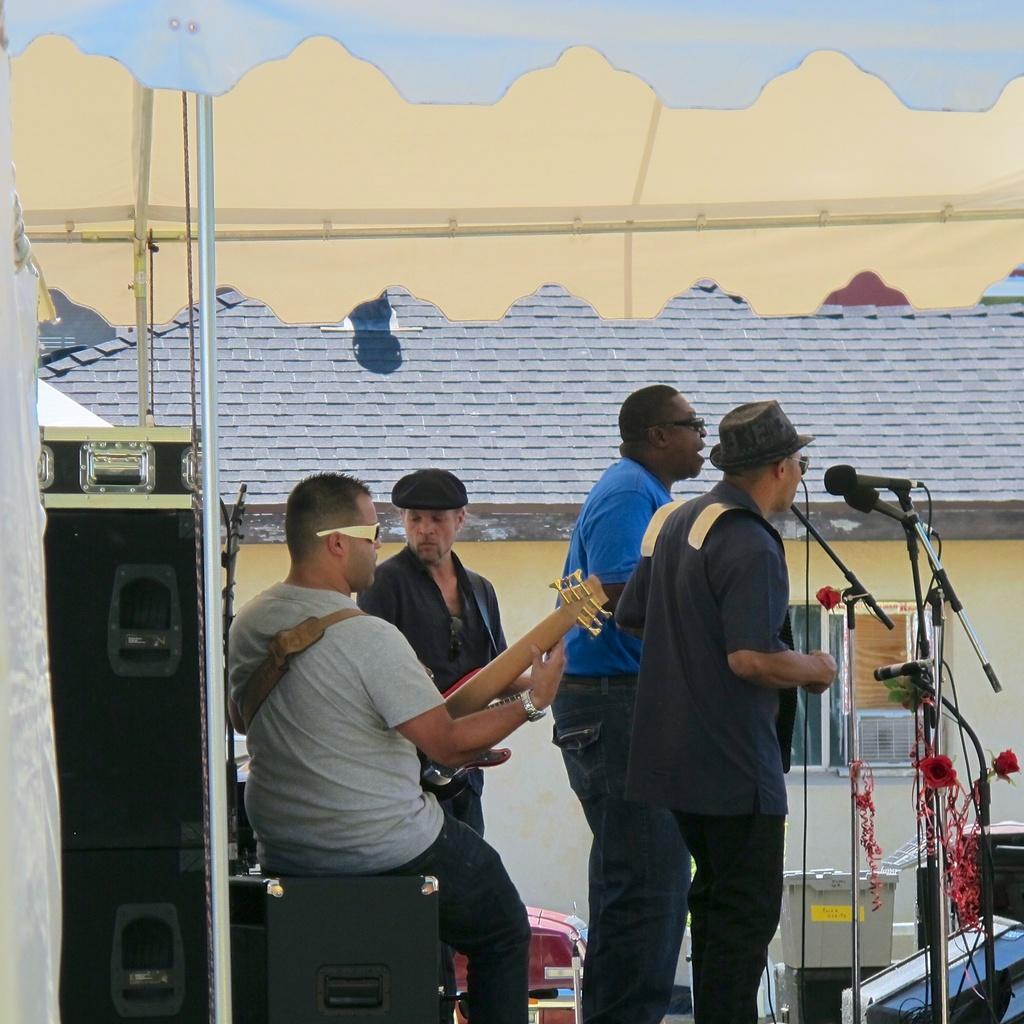Please provide a concise description of this image. In this image there are people playing musical instruments. In front of them there are mike's. Beside them there are a few objects. In the background of the image there is a building. On the left side of the image there is a speaker. 